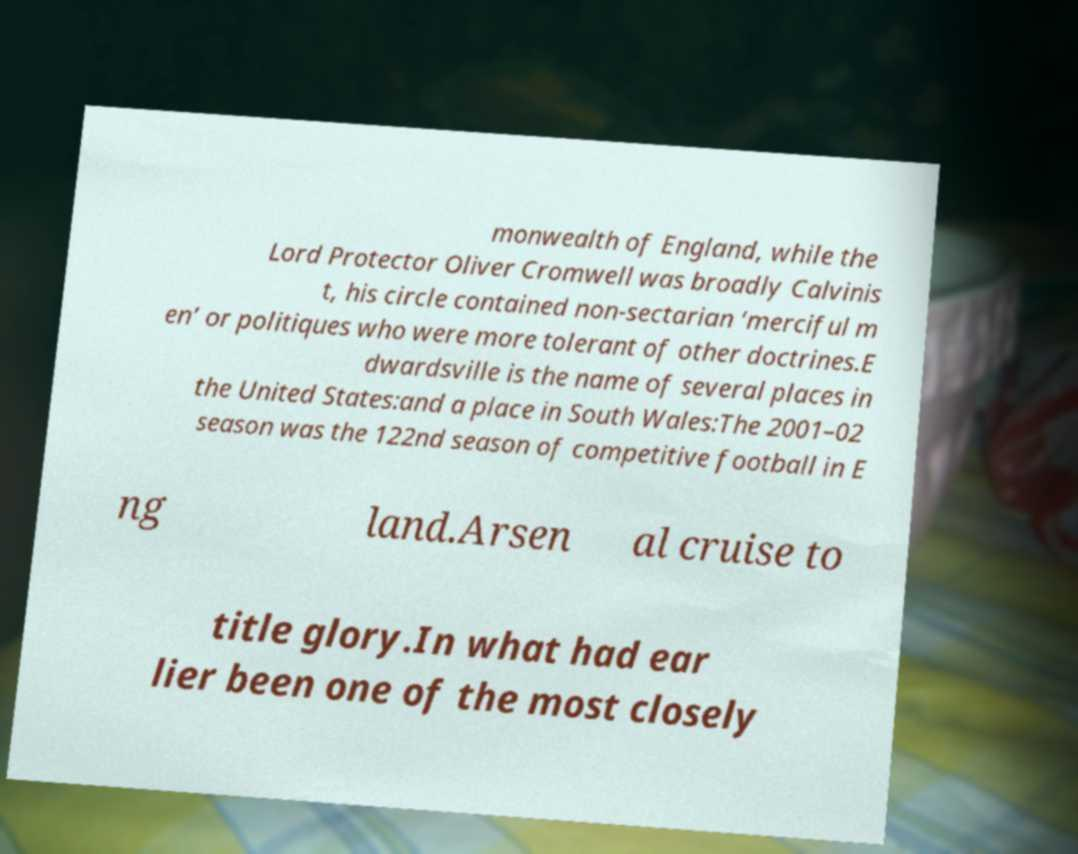Could you assist in decoding the text presented in this image and type it out clearly? monwealth of England, while the Lord Protector Oliver Cromwell was broadly Calvinis t, his circle contained non-sectarian ‘merciful m en’ or politiques who were more tolerant of other doctrines.E dwardsville is the name of several places in the United States:and a place in South Wales:The 2001–02 season was the 122nd season of competitive football in E ng land.Arsen al cruise to title glory.In what had ear lier been one of the most closely 